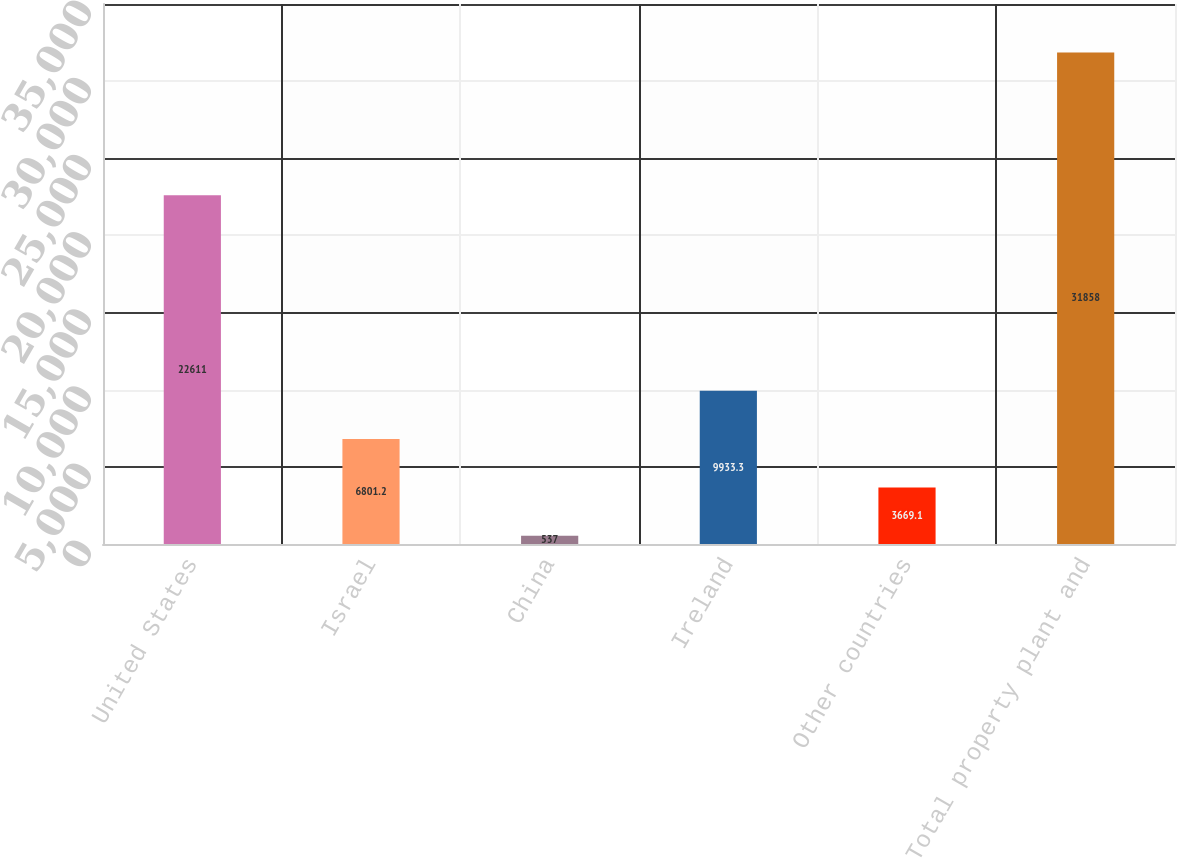<chart> <loc_0><loc_0><loc_500><loc_500><bar_chart><fcel>United States<fcel>Israel<fcel>China<fcel>Ireland<fcel>Other countries<fcel>Total property plant and<nl><fcel>22611<fcel>6801.2<fcel>537<fcel>9933.3<fcel>3669.1<fcel>31858<nl></chart> 